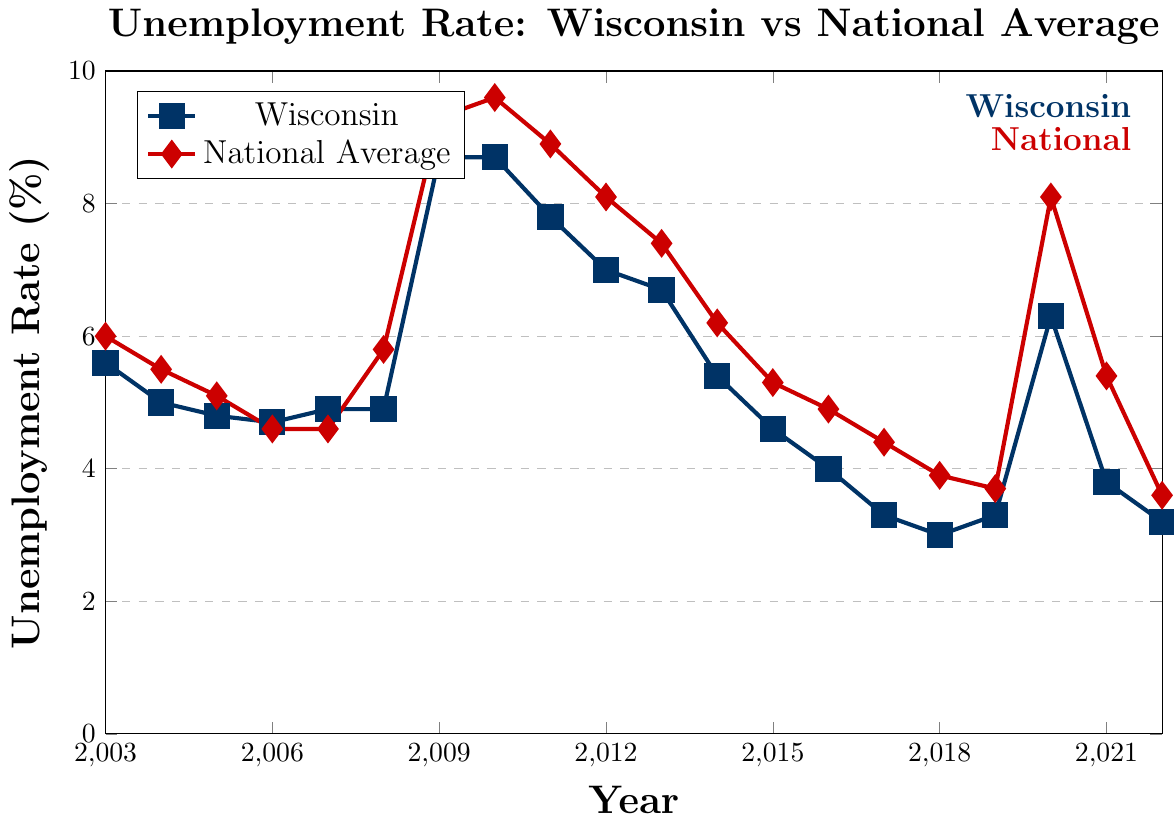What year did Wisconsin have the highest unemployment rate? Look at the highest point on the Wisconsin line and find the corresponding year. The highest unemployment rate for Wisconsin was in 2009 and 2010, both at 8.7%.
Answer: 2009 and 2010 In which year was the national unemployment rate lowest? Look for the lowest point on the national average line and identify the year. The lowest national unemployment rate was in 2019 at 3.7%.
Answer: 2019 How many years did Wisconsin have a higher unemployment rate than the national average? Compare the lines year by year. Wisconsin had a higher unemployment rate than the national average in 2006, 2007, 2017, 2022.
Answer: 4 years Calculate the average unemployment rate of Wisconsin from 2003 to 2022. Sum up all the unemployment rates for Wisconsin from 2003 to 2022 and divide by the number of years (20). The calculation is (5.6 + 5.0 + 4.8 + 4.7 + 4.9 + 4.9 + 8.7 + 8.7 + 7.8 + 7.0 + 6.7 + 5.4 + 4.6 + 4.0 + 3.3 + 3.0 + 3.3 + 6.3 + 3.8 + 3.2) / 20 = 5.22.
Answer: 5.22% Did Wisconsin's unemployment rate ever drop below 4%? If so, in which years? Look at the Wisconsin line and see if it dips below 4%. It went below 4% in 2017, 2018, 2019, and 2022.
Answer: 2017, 2018, 2019, 2022 By how much did the national unemployment rate increase from 2019 to 2020? Subtract the national unemployment rate in 2019 from that in 2020. The increase is 8.1% - 3.7% = 4.4%.
Answer: 4.4% What is the difference between Wisconsin's and the national unemployment rates in 2020? Find the difference between the unemployment rates of Wisconsin and the national average in 2020. The difference is 8.1% - 6.3% = 1.8%.
Answer: 1.8% Which year had the closest unemployment rate between Wisconsin and the national average? Look for the points where the lines of Wisconsin and the national average are closest to each other. In 2006, the rates were very close, with Wisconsin at 4.7% and the national average at 4.6%.
Answer: 2006 Compare the trend of unemployment rates for Wisconsin and the national average from 2003 to 2022. Describe the general pattern of both lines over time. Both trends show an initial decrease followed by a peak around 2009-2010, then a subsequent decrease again, with another spike in 2020 due to COVID-19, and finally, a decrease towards 2022.
Answer: Similar trends with peaks in 2009-2010 and 2020 What is the difference in the unemployment rate between the national average and Wisconsin in 2022? Subtract Wisconsin's unemployment rate in 2022 from the national average unemployment rate in 2022. The difference is 3.6% - 3.2% = 0.4%.
Answer: 0.4% 